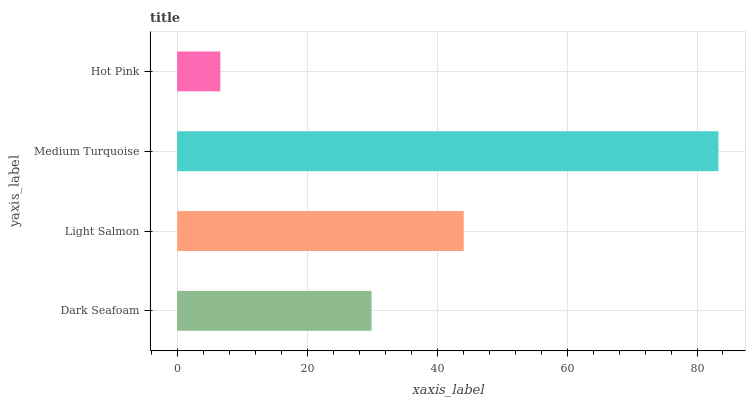Is Hot Pink the minimum?
Answer yes or no. Yes. Is Medium Turquoise the maximum?
Answer yes or no. Yes. Is Light Salmon the minimum?
Answer yes or no. No. Is Light Salmon the maximum?
Answer yes or no. No. Is Light Salmon greater than Dark Seafoam?
Answer yes or no. Yes. Is Dark Seafoam less than Light Salmon?
Answer yes or no. Yes. Is Dark Seafoam greater than Light Salmon?
Answer yes or no. No. Is Light Salmon less than Dark Seafoam?
Answer yes or no. No. Is Light Salmon the high median?
Answer yes or no. Yes. Is Dark Seafoam the low median?
Answer yes or no. Yes. Is Medium Turquoise the high median?
Answer yes or no. No. Is Hot Pink the low median?
Answer yes or no. No. 